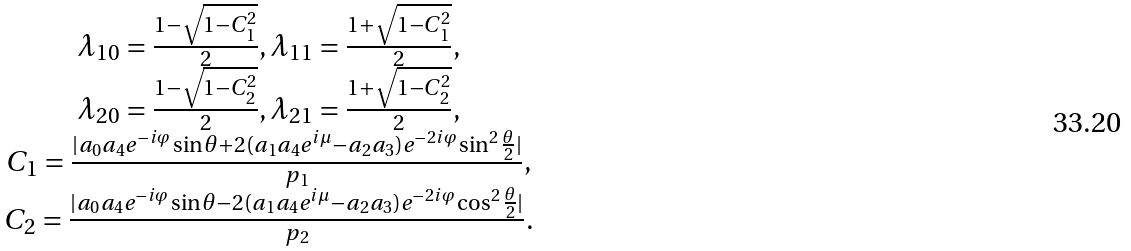<formula> <loc_0><loc_0><loc_500><loc_500>\begin{array} { c } \lambda _ { 1 0 } = \frac { 1 - \sqrt { 1 - C _ { 1 } ^ { 2 } } } { 2 } , \lambda _ { 1 1 } = \frac { 1 + \sqrt { 1 - C _ { 1 } ^ { 2 } } } { 2 } , \\ \lambda _ { 2 0 } = \frac { 1 - \sqrt { 1 - C _ { 2 } ^ { 2 } } } { 2 } , \lambda _ { 2 1 } = \frac { 1 + \sqrt { 1 - C _ { 2 } ^ { 2 } } } { 2 } , \\ C _ { 1 } = \frac { | a _ { 0 } a _ { 4 } e ^ { - i \varphi } \sin \theta + 2 ( a _ { 1 } a _ { 4 } e ^ { i \mu } - a _ { 2 } a _ { 3 } ) e ^ { - 2 i \varphi } \sin ^ { 2 } \frac { \theta } { 2 } | } { p _ { 1 } } , \\ C _ { 2 } = \frac { | a _ { 0 } a _ { 4 } e ^ { - i \varphi } \sin \theta - 2 ( a _ { 1 } a _ { 4 } e ^ { i \mu } - a _ { 2 } a _ { 3 } ) e ^ { - 2 i \varphi } \cos ^ { 2 } \frac { \theta } { 2 } | } { p _ { 2 } } . \end{array}</formula> 